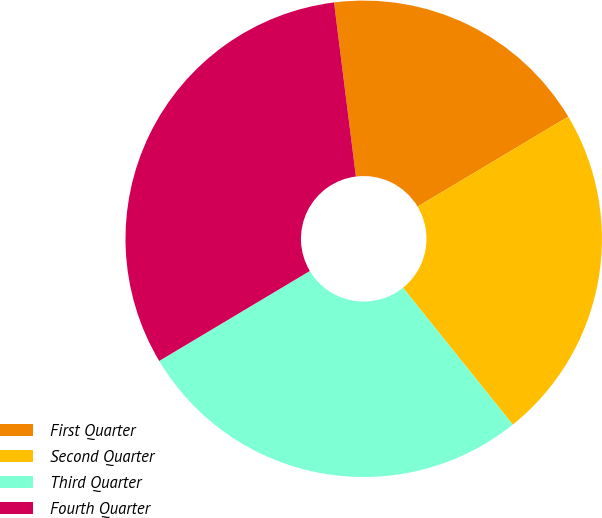Convert chart. <chart><loc_0><loc_0><loc_500><loc_500><pie_chart><fcel>First Quarter<fcel>Second Quarter<fcel>Third Quarter<fcel>Fourth Quarter<nl><fcel>18.42%<fcel>22.81%<fcel>27.19%<fcel>31.58%<nl></chart> 